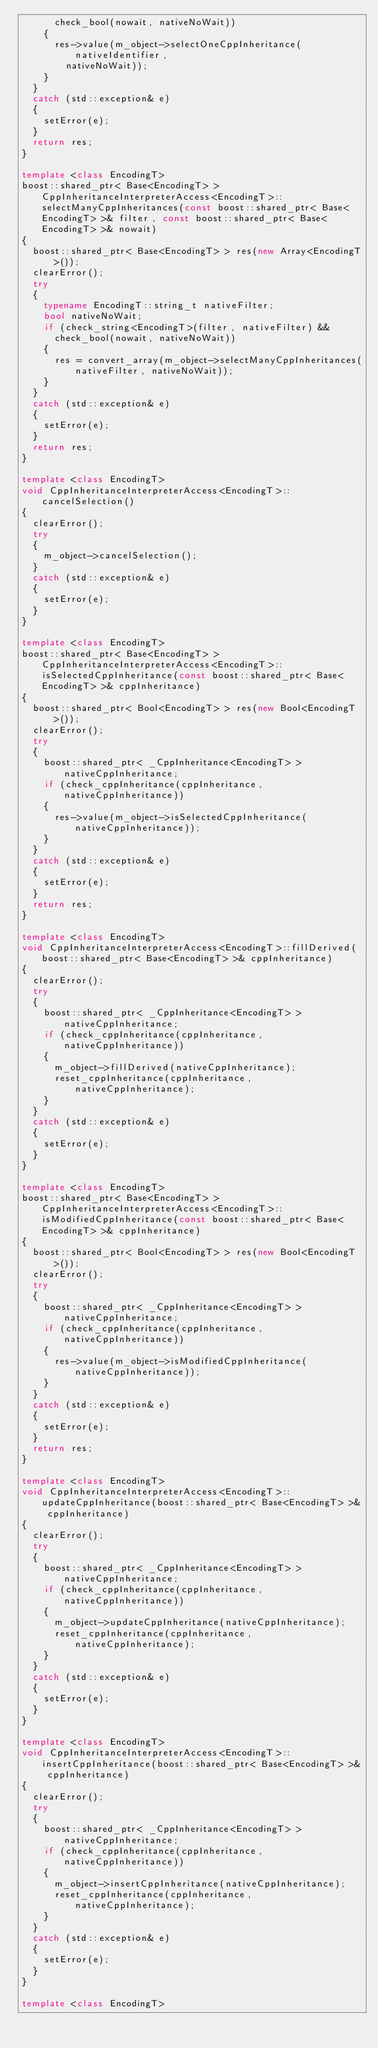Convert code to text. <code><loc_0><loc_0><loc_500><loc_500><_C++_>			check_bool(nowait, nativeNoWait))
		{
			res->value(m_object->selectOneCppInheritance(nativeIdentifier,
				nativeNoWait));
		}
	}
	catch (std::exception& e)
	{
		setError(e);
	}
	return res;
}

template <class EncodingT>
boost::shared_ptr< Base<EncodingT> > CppInheritanceInterpreterAccess<EncodingT>::selectManyCppInheritances(const boost::shared_ptr< Base<EncodingT> >& filter, const boost::shared_ptr< Base<EncodingT> >& nowait)
{
	boost::shared_ptr< Base<EncodingT> > res(new Array<EncodingT>());
	clearError();
	try
	{
		typename EncodingT::string_t nativeFilter;
		bool nativeNoWait;
		if (check_string<EncodingT>(filter, nativeFilter) &&
			check_bool(nowait, nativeNoWait))
		{
			res = convert_array(m_object->selectManyCppInheritances(nativeFilter, nativeNoWait));
		}
	}
	catch (std::exception& e)
	{
		setError(e);
	}
	return res;
}

template <class EncodingT>
void CppInheritanceInterpreterAccess<EncodingT>::cancelSelection()
{
	clearError();
	try
	{
		m_object->cancelSelection();
	}
	catch (std::exception& e)
	{
		setError(e);
	}
}

template <class EncodingT>
boost::shared_ptr< Base<EncodingT> > CppInheritanceInterpreterAccess<EncodingT>::isSelectedCppInheritance(const boost::shared_ptr< Base<EncodingT> >& cppInheritance)
{
	boost::shared_ptr< Bool<EncodingT> > res(new Bool<EncodingT>());
	clearError();
	try
	{
		boost::shared_ptr< _CppInheritance<EncodingT> > nativeCppInheritance;
		if (check_cppInheritance(cppInheritance, nativeCppInheritance))
		{
			res->value(m_object->isSelectedCppInheritance(nativeCppInheritance));
		}
	}
	catch (std::exception& e)
	{
		setError(e);
	}
	return res;
}

template <class EncodingT>
void CppInheritanceInterpreterAccess<EncodingT>::fillDerived(boost::shared_ptr< Base<EncodingT> >& cppInheritance)
{
	clearError();
	try
	{
		boost::shared_ptr< _CppInheritance<EncodingT> > nativeCppInheritance;
		if (check_cppInheritance(cppInheritance, nativeCppInheritance))
		{
			m_object->fillDerived(nativeCppInheritance);
			reset_cppInheritance(cppInheritance, nativeCppInheritance);
		}
	}
	catch (std::exception& e)
	{
		setError(e);
	}
}

template <class EncodingT>
boost::shared_ptr< Base<EncodingT> > CppInheritanceInterpreterAccess<EncodingT>::isModifiedCppInheritance(const boost::shared_ptr< Base<EncodingT> >& cppInheritance)
{
	boost::shared_ptr< Bool<EncodingT> > res(new Bool<EncodingT>());
	clearError();
	try
	{
		boost::shared_ptr< _CppInheritance<EncodingT> > nativeCppInheritance;
		if (check_cppInheritance(cppInheritance, nativeCppInheritance))
		{
			res->value(m_object->isModifiedCppInheritance(nativeCppInheritance));
		}
	}
	catch (std::exception& e)
	{
		setError(e);
	}
	return res;
}

template <class EncodingT>
void CppInheritanceInterpreterAccess<EncodingT>::updateCppInheritance(boost::shared_ptr< Base<EncodingT> >& cppInheritance)
{
	clearError();
	try
	{
		boost::shared_ptr< _CppInheritance<EncodingT> > nativeCppInheritance;
		if (check_cppInheritance(cppInheritance, nativeCppInheritance))
		{
			m_object->updateCppInheritance(nativeCppInheritance);
			reset_cppInheritance(cppInheritance, nativeCppInheritance);
		}
	}
	catch (std::exception& e)
	{
		setError(e);
	}
}

template <class EncodingT>
void CppInheritanceInterpreterAccess<EncodingT>::insertCppInheritance(boost::shared_ptr< Base<EncodingT> >& cppInheritance)
{
	clearError();
	try
	{
		boost::shared_ptr< _CppInheritance<EncodingT> > nativeCppInheritance;
		if (check_cppInheritance(cppInheritance, nativeCppInheritance))
		{
			m_object->insertCppInheritance(nativeCppInheritance);
			reset_cppInheritance(cppInheritance, nativeCppInheritance);
		}
	}
	catch (std::exception& e)
	{
		setError(e);
	}
}

template <class EncodingT></code> 